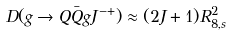<formula> <loc_0><loc_0><loc_500><loc_500>D ( g \rightarrow Q \bar { Q } g J ^ { - + } ) \approx ( 2 J + 1 ) R _ { 8 , s } ^ { 2 }</formula> 